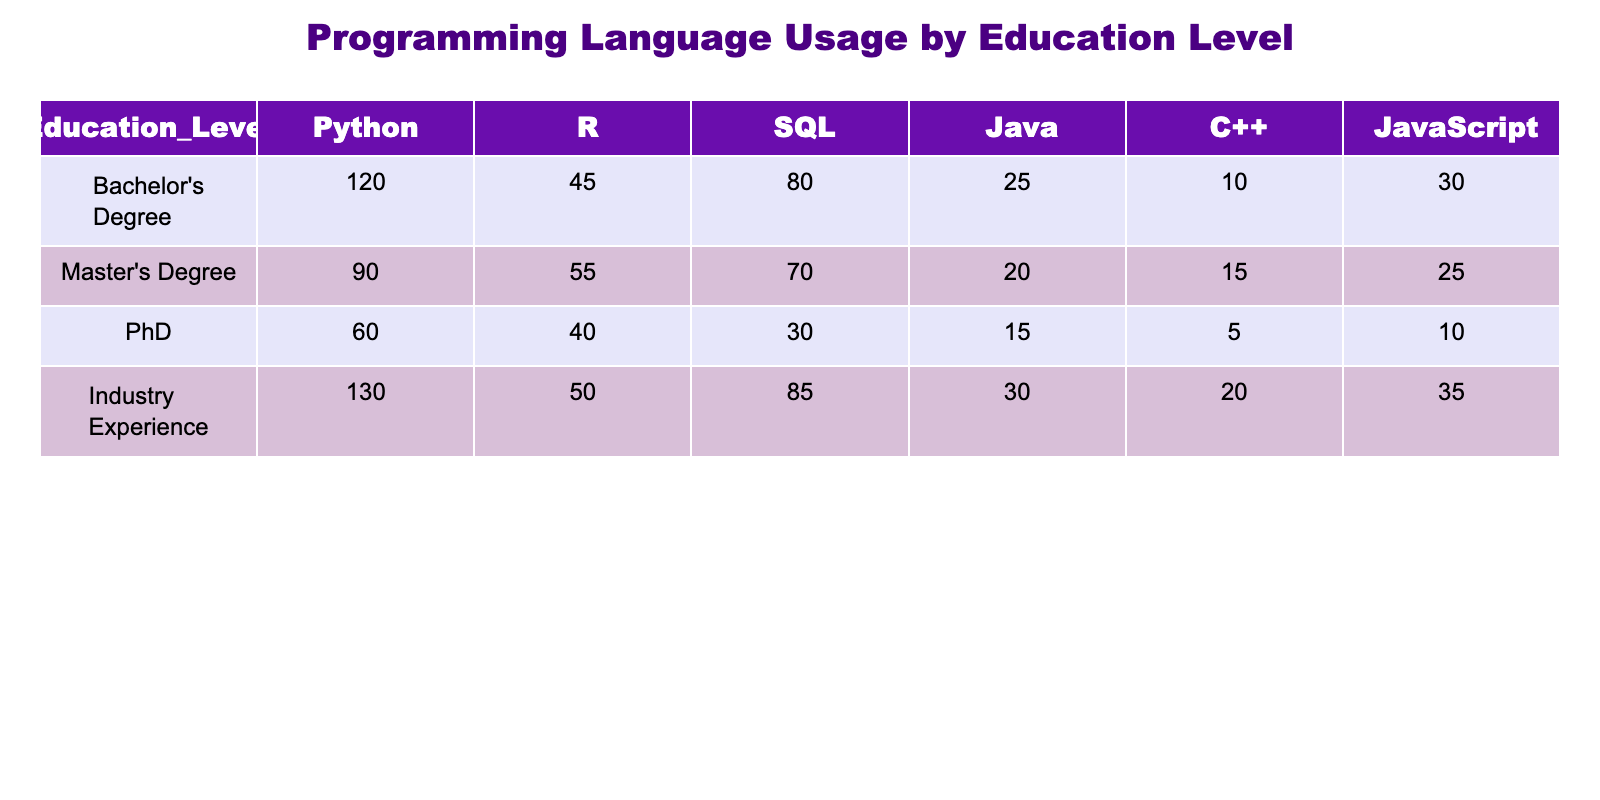What is the highest frequency of Python usage among the education levels? The highest frequency of Python usage is observed in the "Industry Experience" category with a count of 130.
Answer: 130 How many people use Java in total across all education levels? To find the total Java usage, we sum the values from each level: 25 (Bachelor's) + 20 (Master's) + 15 (PhD) + 30 (Industry) = 90.
Answer: 90 Is the frequency of SQL usage higher in Master’s Degree holders compared to PhD holders? The SQL usage is 70 for Master's Degree holders and 30 for PhD holders, which shows that Master's holders use SQL more frequently than PhD holders.
Answer: Yes What is the average frequency of C++ usage across all education levels? Adding the C++ values: 10 (Bachelor's) + 15 (Master's) + 5 (PhD) + 20 (Industry) = 50. There are 4 categories, so the average is 50/4 = 12.5.
Answer: 12.5 Which education level has the least usage of JavaScript? In the "PhD" category, the frequency of JavaScript usage is the lowest at 10.
Answer: PhD Among Bachelor's Degree and Industry Experience holders, who uses R more frequently? The R usage for Bachelor's Degree holders is 45, while for Industry Experience holders it is 50. Since 50 is greater than 45, Industry Experience holders use R more frequently.
Answer: Industry Experience What is the total frequency of programming language usage for Master’s Degree holders? The total is calculated by summing all the language frequencies for Master’s Degree: 90 (Python) + 55 (R) + 70 (SQL) + 20 (Java) + 15 (C++) + 25 (JavaScript) = 265.
Answer: 265 Is there a programming language that is used equally by both Bachelor's and Industry Experience? Comparing both education levels, Python (120 for Bachelor's and 130 for Industry), R (45 vs 50), SQL (80 vs 85), Java (25 vs 30), C++ (10 vs 20), and JavaScript (30 vs 35) shows that no programming language counts are equal.
Answer: No What is the difference in frequency of SQL usage between Bachelor's Degree holders and Industry Experience? The SQL usage for Bachelor’s is 80, and for Industry Experience, it is 85. The difference is 85 - 80 = 5.
Answer: 5 